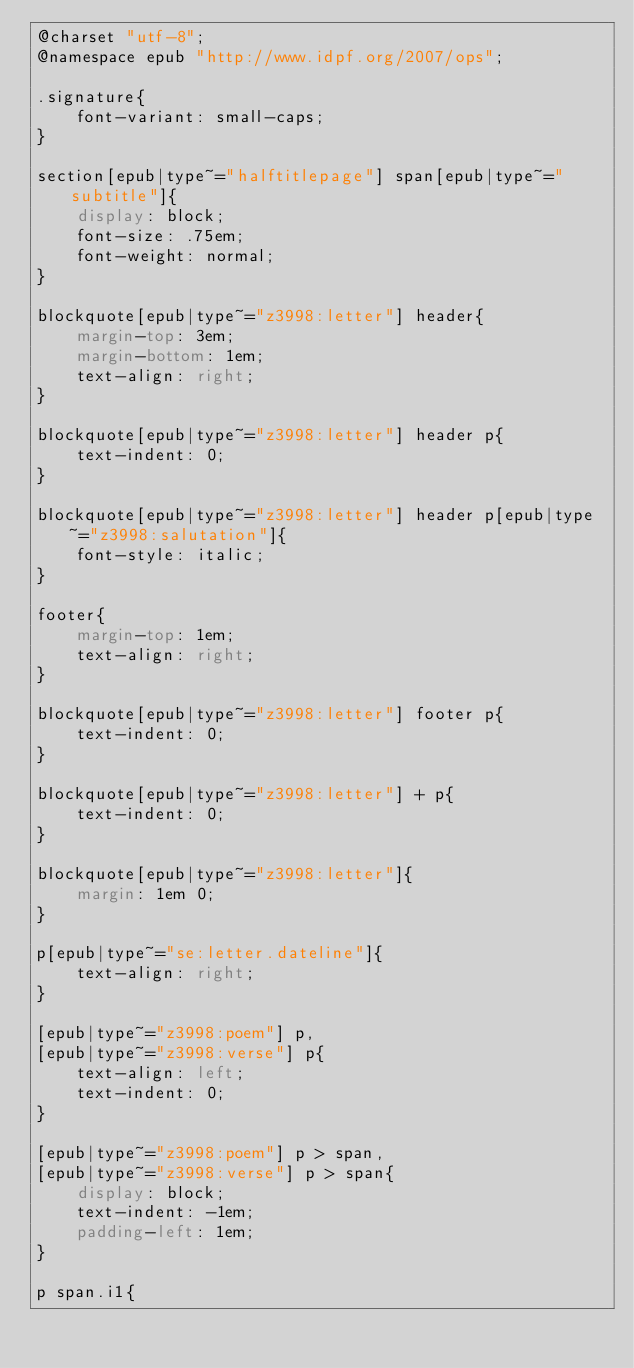<code> <loc_0><loc_0><loc_500><loc_500><_CSS_>@charset "utf-8";
@namespace epub "http://www.idpf.org/2007/ops";

.signature{
	font-variant: small-caps;
}

section[epub|type~="halftitlepage"] span[epub|type~="subtitle"]{
	display: block;
	font-size: .75em;
	font-weight: normal;
}

blockquote[epub|type~="z3998:letter"] header{
	margin-top: 3em;
	margin-bottom: 1em;
	text-align: right;
}

blockquote[epub|type~="z3998:letter"] header p{
	text-indent: 0;
}

blockquote[epub|type~="z3998:letter"] header p[epub|type~="z3998:salutation"]{
	font-style: italic;
}

footer{
	margin-top: 1em;
	text-align: right;
}

blockquote[epub|type~="z3998:letter"] footer p{
	text-indent: 0;
}

blockquote[epub|type~="z3998:letter"] + p{
	text-indent: 0;
}

blockquote[epub|type~="z3998:letter"]{
	margin: 1em 0;
}

p[epub|type~="se:letter.dateline"]{
	text-align: right;
}

[epub|type~="z3998:poem"] p,
[epub|type~="z3998:verse"] p{
	text-align: left;
	text-indent: 0;
}

[epub|type~="z3998:poem"] p > span,
[epub|type~="z3998:verse"] p > span{
	display: block;
	text-indent: -1em;
	padding-left: 1em;
}

p span.i1{</code> 